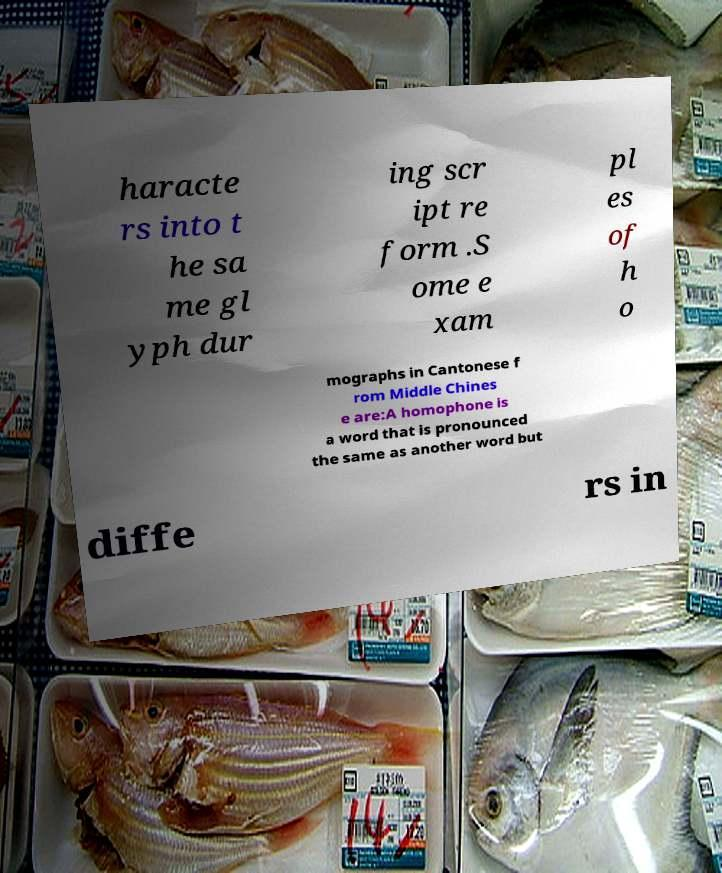I need the written content from this picture converted into text. Can you do that? haracte rs into t he sa me gl yph dur ing scr ipt re form .S ome e xam pl es of h o mographs in Cantonese f rom Middle Chines e are:A homophone is a word that is pronounced the same as another word but diffe rs in 